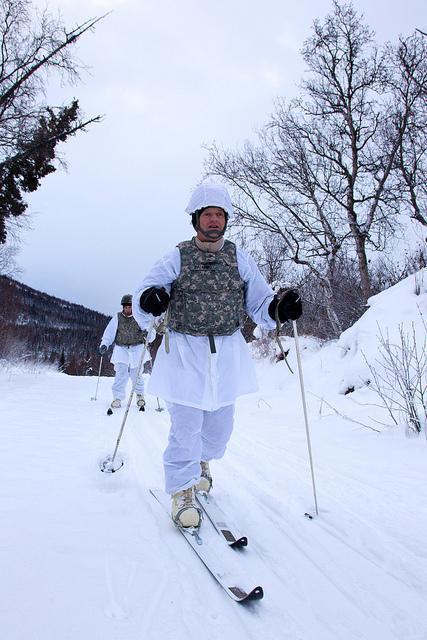Why does he have on that type of vest?
Select the correct answer and articulate reasoning with the following format: 'Answer: answer
Rationale: rationale.'
Options: Avoiding bullet, blending in, standing out, carry items. Answer: blending in.
Rationale: The man's clothes are the same color as the snow. 